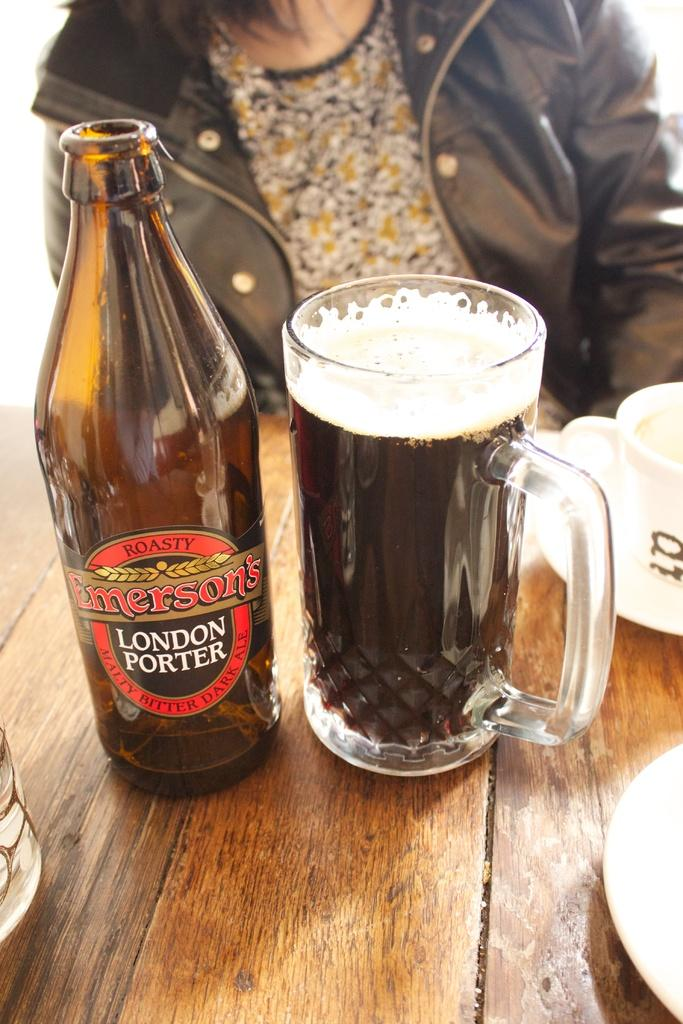<image>
Provide a brief description of the given image. A bottle of Emerson's London Porter sits next to a full beer mug on a table with a woman sitting in the background. 